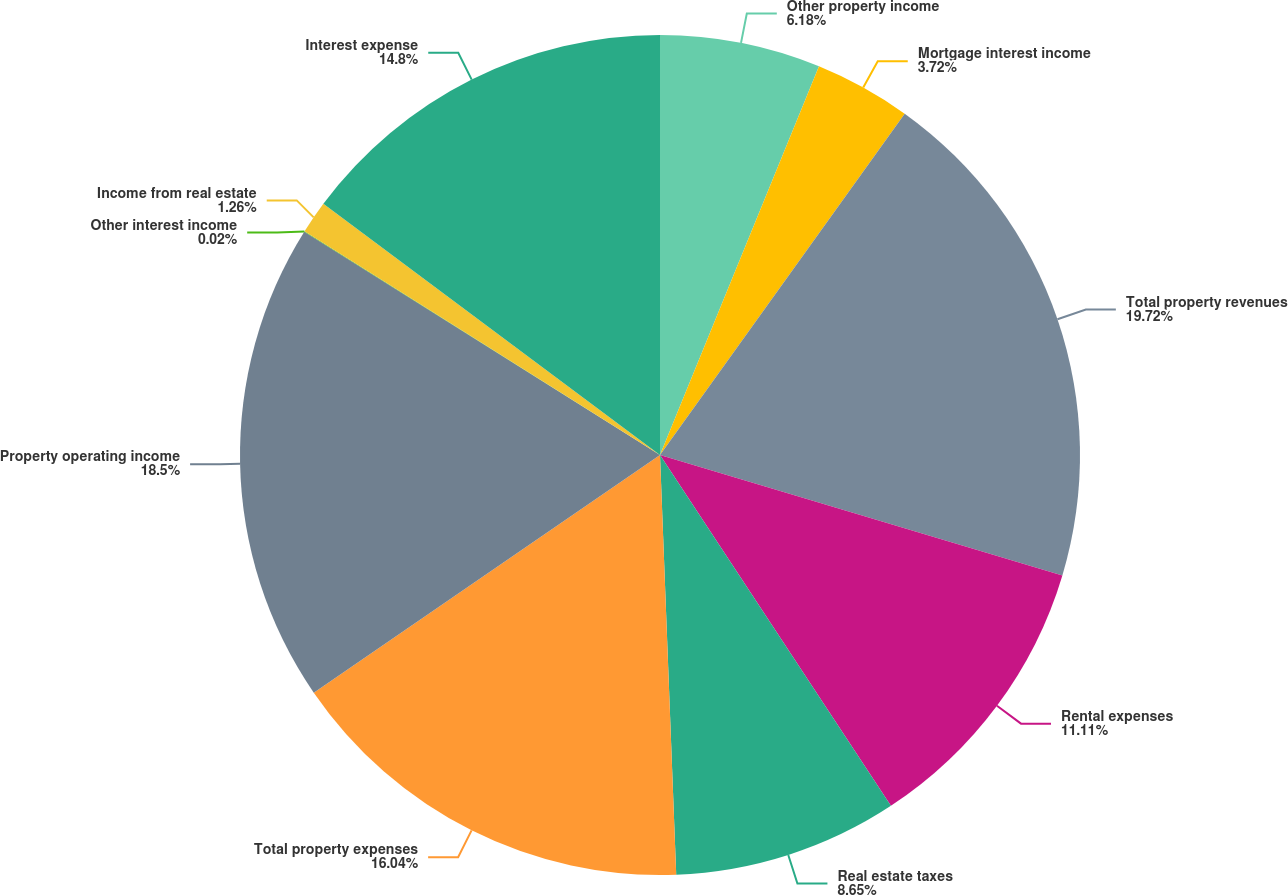<chart> <loc_0><loc_0><loc_500><loc_500><pie_chart><fcel>Other property income<fcel>Mortgage interest income<fcel>Total property revenues<fcel>Rental expenses<fcel>Real estate taxes<fcel>Total property expenses<fcel>Property operating income<fcel>Other interest income<fcel>Income from real estate<fcel>Interest expense<nl><fcel>6.18%<fcel>3.72%<fcel>19.73%<fcel>11.11%<fcel>8.65%<fcel>16.04%<fcel>18.5%<fcel>0.02%<fcel>1.26%<fcel>14.8%<nl></chart> 